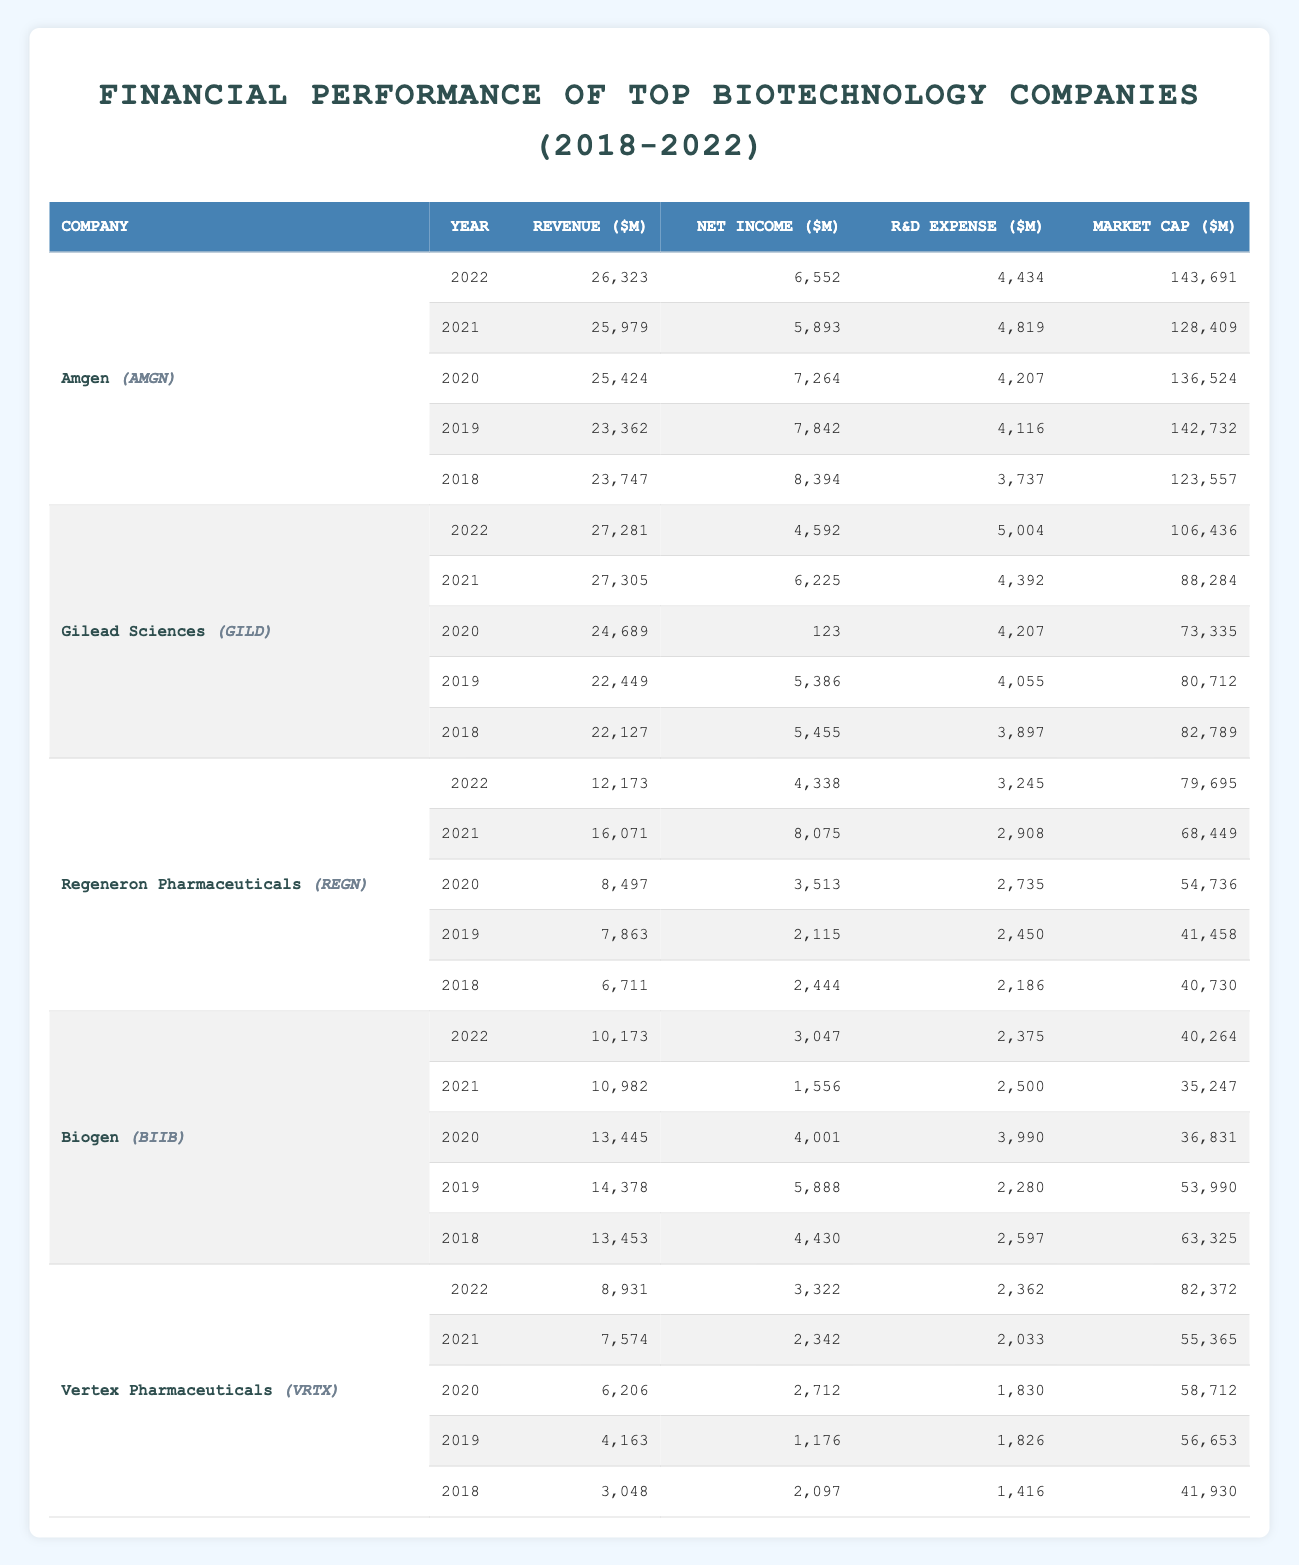What was Amgen's revenue in 2020? Looking at the row for Amgen in the year 2020, the revenue is listed as 25,424 million dollars.
Answer: 25,424 What is the total net income of Gilead Sciences over the years 2018 to 2022? To find the total net income, we add the net income values for Gilead Sciences: 5,455 + 5,386 + 123 + 6,225 + 4,592 = 21,781 million dollars.
Answer: 21,781 Was Vertex Pharmaceuticals' market cap higher in 2022 compared to 2019? In 2022, Vertex's market cap is 82,372 million dollars, while in 2019 it is 56,653 million dollars, which means 82,372 > 56,653. Therefore, the statement is true.
Answer: Yes What has been the trend in R&D expenses for Biogen from 2018 to 2022? The R&D expenses for Biogen over the years are: 2,597 (2018), 2,280 (2019), 3,990 (2020), 2,500 (2021), and 2,375 (2022). Observing these values, we see fluctuations being a decrease from 2018 to 2019, an increase in 2020, then a decrease in 2021, followed by a small decrease in 2022. Overall, there is not a clear upward or downward trend.
Answer: Fluctuating What is the average revenue for Regeneron Pharmaceuticals over the five years? The revenues are: 6,711 (2018), 7,863 (2019), 8,497 (2020), 16,071 (2021), and 12,173 (2022). Summing them gives 51,315 million dollars; dividing by 5 gives an average of 10,263 million dollars.
Answer: 10,263 How much did Amgen spend on R&D in total from 2018 to 2022? Amgen's R&D expenses are: 3,737 (2018), 4,116 (2019), 4,207 (2020), 4,819 (2021), and 4,434 (2022). Summing these gives a total of 21,313 million dollars.
Answer: 21,313 Which company had the highest revenue in 2021? In the year 2021, Amgen's revenue is 25,979, Gilead's is 27,305, Regeneron's is 16,071, Biogen's is 10,982, and Vertex's is 7,574. The highest among these is Gilead Sciences with 27,305 million dollars.
Answer: Gilead Sciences Was there a year when Gilead Sciences had a significantly low net income? In 2020, Gilead Sciences reported a net income of only 123 million dollars, which is significantly lower compared to other years (over 5,000 million)
Answer: Yes What are the total revenues for Vertex Pharmaceuticals from 2018 to 2022? Vertex's revenues are: 3,048 (2018), 4,163 (2019), 6,206 (2020), 7,574 (2021), and 8,931 (2022). Summing these gives a total revenue of 29,922 million dollars.
Answer: 29,922 